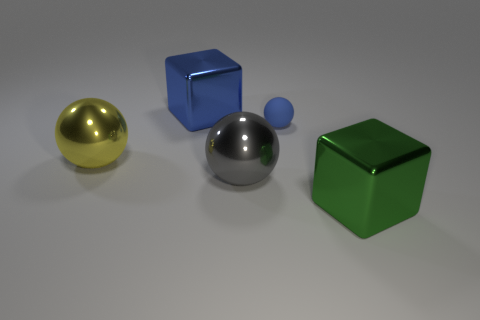Add 1 large purple shiny spheres. How many objects exist? 6 Subtract all spheres. How many objects are left? 2 Add 1 metal spheres. How many metal spheres are left? 3 Add 2 cyan cylinders. How many cyan cylinders exist? 2 Subtract 0 purple balls. How many objects are left? 5 Subtract all big gray metallic spheres. Subtract all metal cubes. How many objects are left? 2 